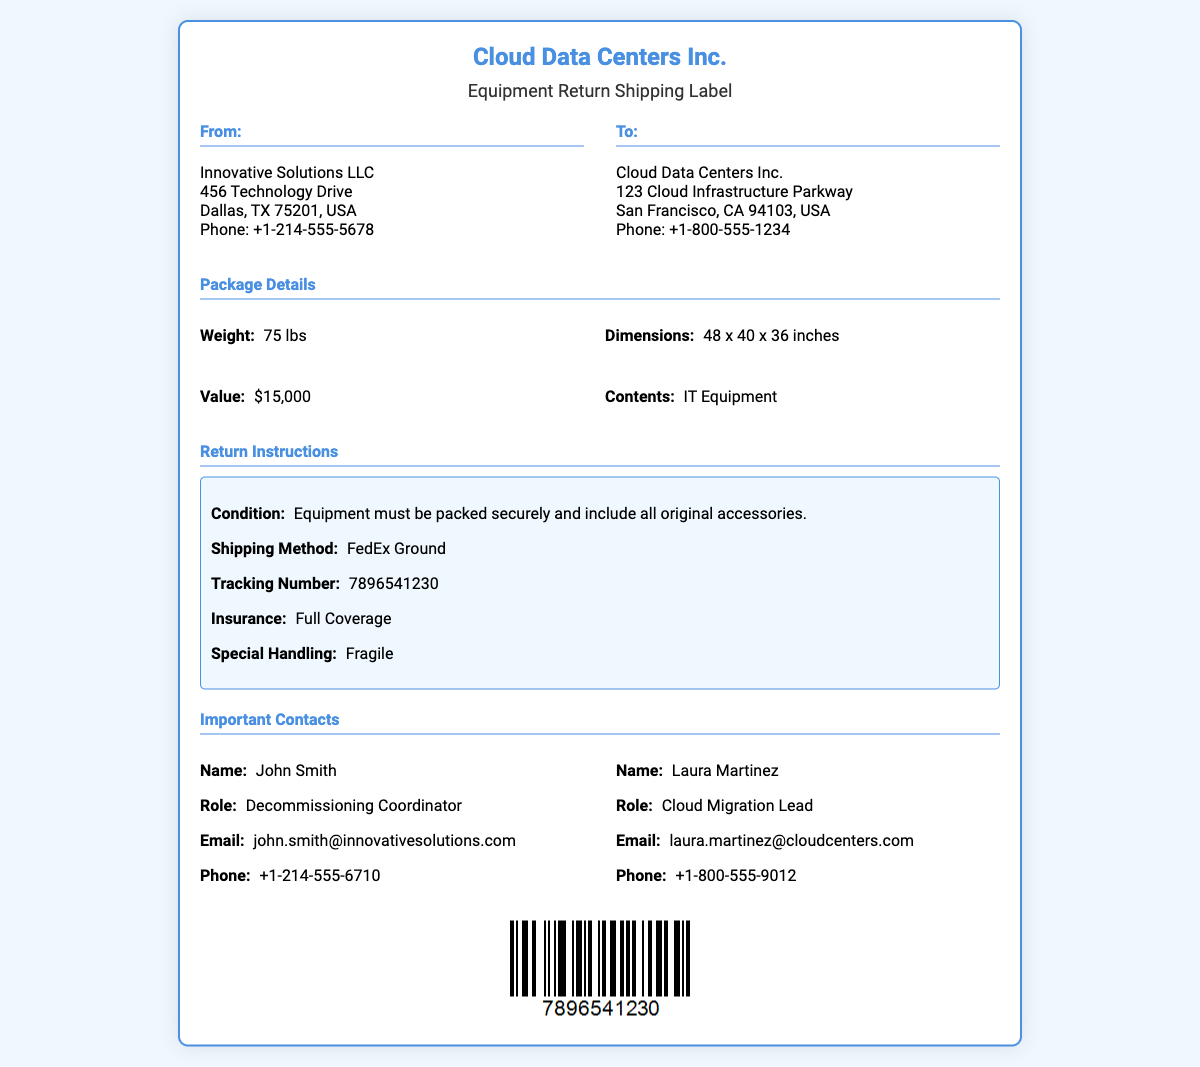What is the shipping method? The shipping method listed in the document is FedEx Ground.
Answer: FedEx Ground What is the weight of the package? The weight of the package mentioned in the document is 75 lbs.
Answer: 75 lbs Who is the return contact for Innovative Solutions LLC? The contact listed is John Smith, who is the Decommissioning Coordinator.
Answer: John Smith What must be included when returning the equipment? The document states that all original accessories must be included with the equipment.
Answer: All original accessories What is the value of the contents being shipped? The stated value of the contents in the document is $15,000.
Answer: $15,000 What is the tracking number for this shipment? The tracking number provided in the document is 7896541230.
Answer: 7896541230 What type of insurance is applied to the shipment? The document specifies that the insurance is Full Coverage.
Answer: Full Coverage What is the dimension of the package? The dimensions of the package specified in the document are 48 x 40 x 36 inches.
Answer: 48 x 40 x 36 inches Who is the Cloud Migration Lead? The document identifies Laura Martinez as the Cloud Migration Lead.
Answer: Laura Martinez 